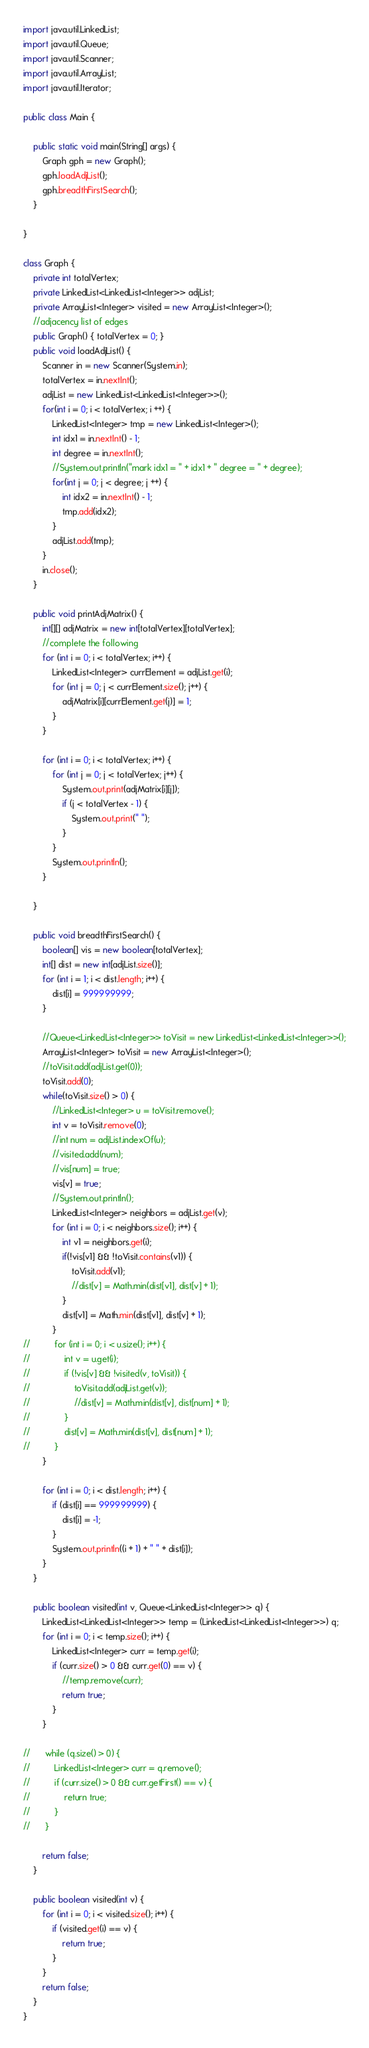Convert code to text. <code><loc_0><loc_0><loc_500><loc_500><_Java_>import java.util.LinkedList;
import java.util.Queue;
import java.util.Scanner;
import java.util.ArrayList;
import java.util.Iterator;

public class Main {

	public static void main(String[] args) {
		Graph gph = new Graph();
		gph.loadAdjList();
		gph.breadthFirstSearch();
	}

}

class Graph {
	private int totalVertex;
	private LinkedList<LinkedList<Integer>> adjList;
	private ArrayList<Integer> visited = new ArrayList<Integer>();
	//adjacency list of edges	
	public Graph() { totalVertex = 0; }
	public void loadAdjList() {
		Scanner in = new Scanner(System.in);
		totalVertex = in.nextInt();
		adjList = new LinkedList<LinkedList<Integer>>();
		for(int i = 0; i < totalVertex; i ++) {
			LinkedList<Integer> tmp = new LinkedList<Integer>();
			int idx1 = in.nextInt() - 1;
			int degree = in.nextInt();
			//System.out.println("mark idx1 = " + idx1 + " degree = " + degree);
			for(int j = 0; j < degree; j ++) {
				int idx2 = in.nextInt() - 1;
				tmp.add(idx2);
			}	
			adjList.add(tmp);
		}
		in.close();
	}
	
	public void printAdjMatrix() {
		int[][] adjMatrix = new int[totalVertex][totalVertex];
		//complete the following
		for (int i = 0; i < totalVertex; i++) {
			LinkedList<Integer> currElement = adjList.get(i);
			for (int j = 0; j < currElement.size(); j++) {
				adjMatrix[i][currElement.get(j)] = 1;
			}
		}
		
		for (int i = 0; i < totalVertex; i++) {
			for (int j = 0; j < totalVertex; j++) {
				System.out.print(adjMatrix[i][j]);
				if (j < totalVertex - 1) {
					System.out.print(" ");
				}
			}
			System.out.println();
		}
		
	}
	
	public void breadthFirstSearch() {
		boolean[] vis = new boolean[totalVertex];
		int[] dist = new int[adjList.size()];
		for (int i = 1; i < dist.length; i++) {
			dist[i] = 999999999;
		}
		
		//Queue<LinkedList<Integer>> toVisit = new LinkedList<LinkedList<Integer>>();
		ArrayList<Integer> toVisit = new ArrayList<Integer>();
		//toVisit.add(adjList.get(0));
		toVisit.add(0);
		while(toVisit.size() > 0) {
			//LinkedList<Integer> u = toVisit.remove();
			int v = toVisit.remove(0);
			//int num = adjList.indexOf(u);
			//visited.add(num);
			//vis[num] = true;
			vis[v] = true;
			//System.out.println();
			LinkedList<Integer> neighbors = adjList.get(v);
			for (int i = 0; i < neighbors.size(); i++) {
				int v1 = neighbors.get(i);
				if(!vis[v1] && !toVisit.contains(v1)) {
					toVisit.add(v1);
					//dist[v] = Math.min(dist[v1], dist[v] + 1);
				}
				dist[v1] = Math.min(dist[v1], dist[v] + 1);
			}
//			for (int i = 0; i < u.size(); i++) {
//				int v = u.get(i);
//				if (!vis[v] && !visited(v, toVisit)) {
//					toVisit.add(adjList.get(v));
//					//dist[v] = Math.min(dist[v], dist[num] + 1);
//				}
//				dist[v] = Math.min(dist[v], dist[num] + 1);
//			}	
		}
		
		for (int i = 0; i < dist.length; i++) {
			if (dist[i] == 999999999) {
				dist[i] = -1;
			}
			System.out.println((i + 1) + " " + dist[i]);
		}
	}
	
	public boolean visited(int v, Queue<LinkedList<Integer>> q) {
		LinkedList<LinkedList<Integer>> temp = (LinkedList<LinkedList<Integer>>) q;
		for (int i = 0; i < temp.size(); i++) { 
			LinkedList<Integer> curr = temp.get(i);
			if (curr.size() > 0 && curr.get(0) == v) {
				//temp.remove(curr);
				return true;
			}
		}
		
//		while (q.size() > 0) {
//			LinkedList<Integer> curr = q.remove();
//			if (curr.size() > 0 && curr.getFirst() == v) {
//				return true;
//			}
//		}

		return false;
	}
	
	public boolean visited(int v) {
		for (int i = 0; i < visited.size(); i++) {
			if (visited.get(i) == v) {
				return true;
			}
		}
		return false;
	}
}
</code> 